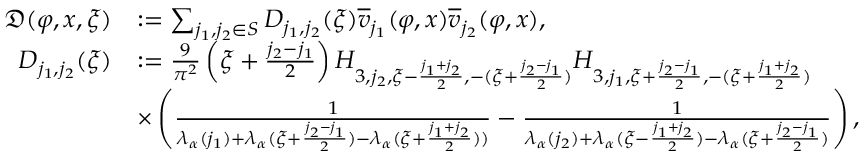Convert formula to latex. <formula><loc_0><loc_0><loc_500><loc_500>\begin{array} { r l } { \mathfrak { D } ( \varphi , x , \xi ) } & { \colon = \sum _ { j _ { 1 } , j _ { 2 } \in S } D _ { j _ { 1 } , j _ { 2 } } ( \xi ) \overline { v } _ { j _ { 1 } } ( \varphi , x ) \overline { v } _ { j _ { 2 } } ( \varphi , x ) , } \\ { D _ { j _ { 1 } , j _ { 2 } } ( \xi ) } & { \colon = \frac { 9 } { \pi ^ { 2 } } \left ( \xi + \frac { j _ { 2 } - j _ { 1 } } { 2 } \right ) H _ { 3 , j _ { 2 } , \xi - \frac { j _ { 1 } + j _ { 2 } } 2 , - ( \xi + \frac { j _ { 2 } - j _ { 1 } } 2 ) } H _ { 3 , j _ { 1 } , \xi + \frac { j _ { 2 } - j _ { 1 } } 2 , - ( \xi + \frac { j _ { 1 } + j _ { 2 } } 2 ) } } \\ & { \times \left ( \frac { 1 } { \lambda _ { \alpha } ( j _ { 1 } ) + \lambda _ { \alpha } ( \xi + \frac { j _ { 2 } - j _ { 1 } } 2 ) - \lambda _ { \alpha } ( \xi + \frac { j _ { 1 } + j _ { 2 } } 2 ) ) } - \frac { 1 } { \lambda _ { \alpha } ( j _ { 2 } ) + \lambda _ { \alpha } ( \xi - \frac { j _ { 1 } + j _ { 2 } } 2 ) - \lambda _ { \alpha } ( \xi + \frac { j _ { 2 } - j _ { 1 } } 2 ) } \right ) , } \end{array}</formula> 